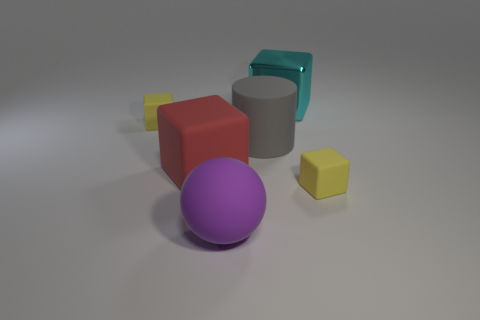Subtract all large rubber cubes. How many cubes are left? 3 Add 2 large red rubber blocks. How many objects exist? 8 Subtract all red cubes. How many cubes are left? 3 Subtract all cylinders. How many objects are left? 5 Subtract all red blocks. Subtract all purple cylinders. How many blocks are left? 3 Subtract all cyan blocks. How many yellow spheres are left? 0 Subtract all cyan metal blocks. Subtract all metal cubes. How many objects are left? 4 Add 1 small matte blocks. How many small matte blocks are left? 3 Add 1 yellow things. How many yellow things exist? 3 Subtract 0 green cylinders. How many objects are left? 6 